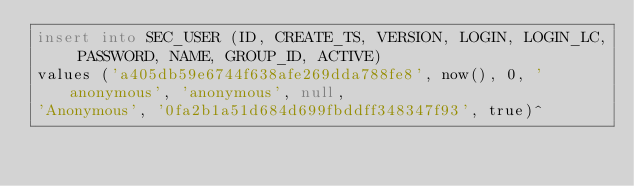<code> <loc_0><loc_0><loc_500><loc_500><_SQL_>insert into SEC_USER (ID, CREATE_TS, VERSION, LOGIN, LOGIN_LC, PASSWORD, NAME, GROUP_ID, ACTIVE)
values ('a405db59e6744f638afe269dda788fe8', now(), 0, 'anonymous', 'anonymous', null,
'Anonymous', '0fa2b1a51d684d699fbddff348347f93', true)^</code> 